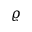<formula> <loc_0><loc_0><loc_500><loc_500>\varrho</formula> 